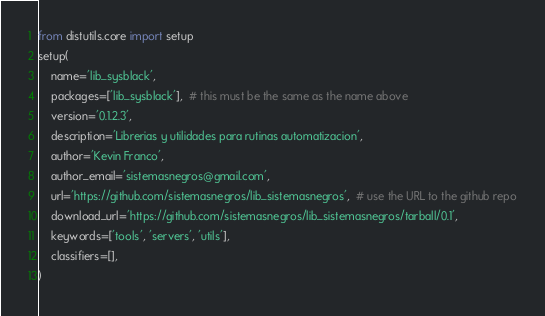Convert code to text. <code><loc_0><loc_0><loc_500><loc_500><_Python_>from distutils.core import setup
setup(
    name='lib_sysblack',
    packages=['lib_sysblack'],  # this must be the same as the name above
    version='0.1.2.3',
    description='Librerias y utilidades para rutinas automatizacion',
    author='Kevin Franco',
    author_email='sistemasnegros@gmail.com',
    url='https://github.com/sistemasnegros/lib_sistemasnegros',  # use the URL to the github repo
    download_url='https://github.com/sistemasnegros/lib_sistemasnegros/tarball/0.1',
    keywords=['tools', 'servers', 'utils'],
    classifiers=[],
)
</code> 